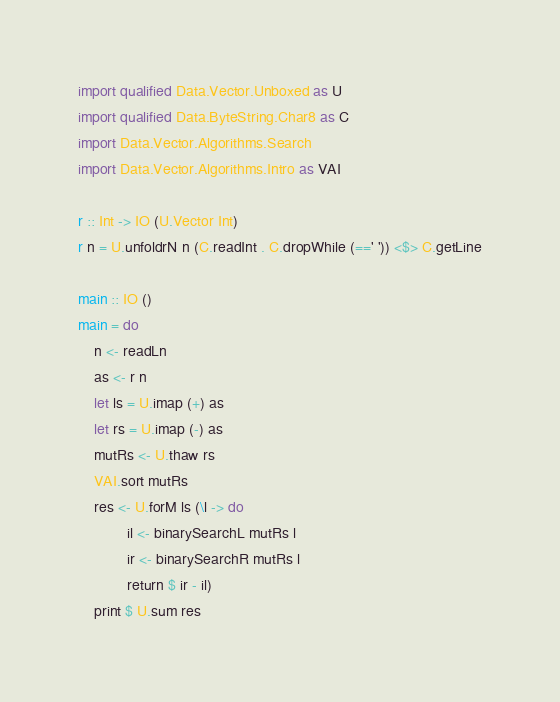Convert code to text. <code><loc_0><loc_0><loc_500><loc_500><_Haskell_>import qualified Data.Vector.Unboxed as U
import qualified Data.ByteString.Char8 as C
import Data.Vector.Algorithms.Search
import Data.Vector.Algorithms.Intro as VAI

r :: Int -> IO (U.Vector Int)
r n = U.unfoldrN n (C.readInt . C.dropWhile (==' ')) <$> C.getLine

main :: IO ()
main = do
    n <- readLn
    as <- r n
    let ls = U.imap (+) as
    let rs = U.imap (-) as
    mutRs <- U.thaw rs
    VAI.sort mutRs
    res <- U.forM ls (\l -> do
            il <- binarySearchL mutRs l
            ir <- binarySearchR mutRs l
            return $ ir - il)
    print $ U.sum res</code> 